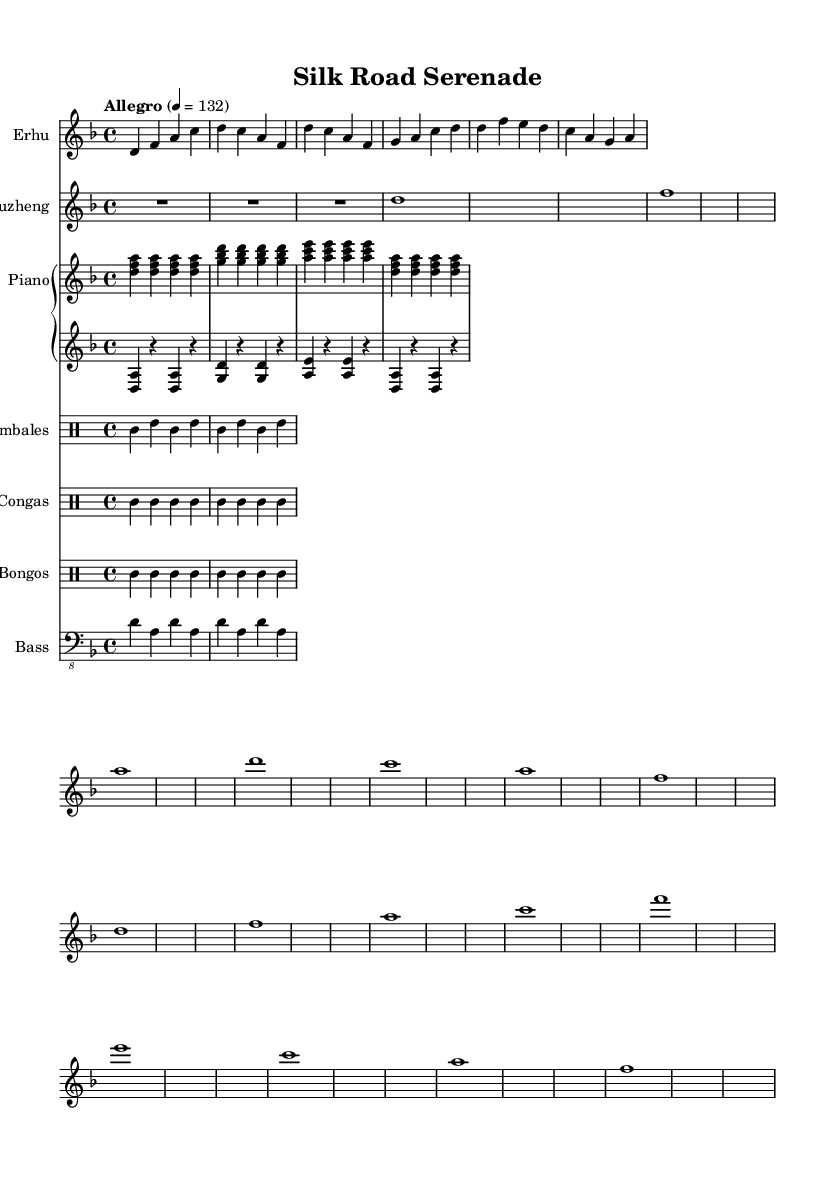What is the key signature of this music? The key signature is D minor, indicated by one flat (B flat) in the score.
Answer: D minor What is the time signature of the piece? The time signature is 4/4, as noted in the beginning of the score, indicating four beats per measure.
Answer: 4/4 What is the tempo marking for this composition? The tempo marking is "Allegro," which indicates a lively and fast tempo, set at 132 beats per minute.
Answer: Allegro Which two instruments provide traditional Chinese elements in the piece? The erhu and guzheng are the two instruments that provide traditional Chinese elements, clearly labeled in the staff names.
Answer: Erhu and Guzheng What type of rhythm is emphasized by the percussion in this music? The congas and timbales introduce a salsa rhythm, as evidenced by the notation patterns that align with traditional Latin music styles.
Answer: Salsa rhythm How many measures are present in the erhu part? The erhu part contains four measures, as identified by the groups of notes divided by vertical bar lines.
Answer: Four measures Identify the function of the bass in this fusion piece. The bass supports the harmonic foundation and rhythm, providing depth and reinforcing the salsa style by playing rhythmic patterns that complement the percussion.
Answer: Harmonic foundation 